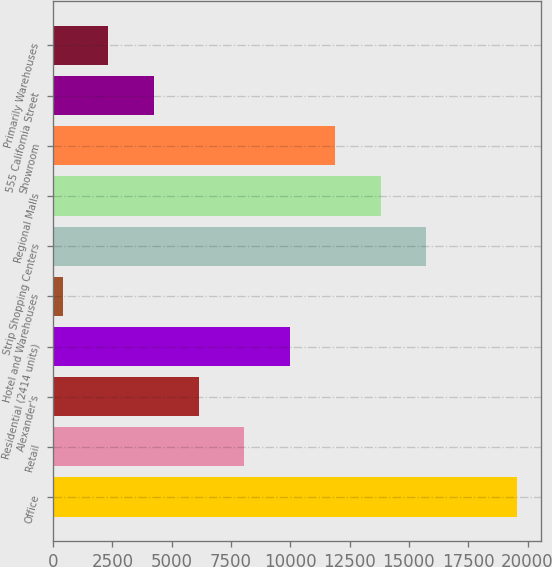Convert chart. <chart><loc_0><loc_0><loc_500><loc_500><bar_chart><fcel>Office<fcel>Retail<fcel>Alexander's<fcel>Residential (2414 units)<fcel>Hotel and Warehouses<fcel>Strip Shopping Centers<fcel>Regional Malls<fcel>Showroom<fcel>555 California Street<fcel>Primarily Warehouses<nl><fcel>19571<fcel>8070.8<fcel>6154.1<fcel>9987.5<fcel>404<fcel>15737.6<fcel>13820.9<fcel>11904.2<fcel>4237.4<fcel>2320.7<nl></chart> 